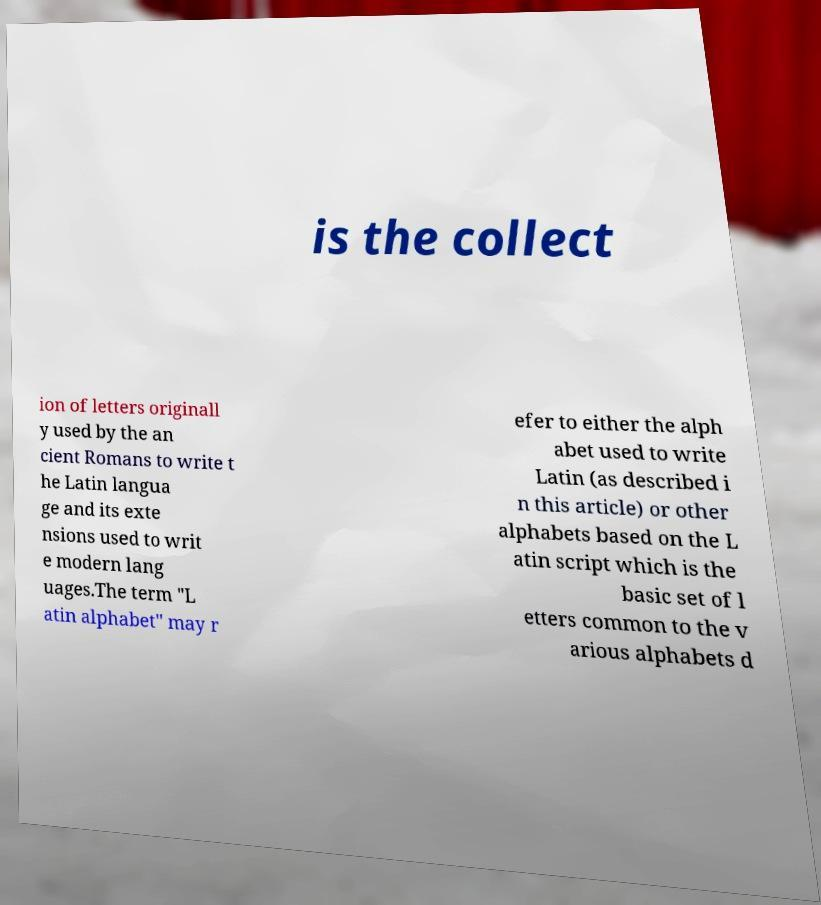I need the written content from this picture converted into text. Can you do that? is the collect ion of letters originall y used by the an cient Romans to write t he Latin langua ge and its exte nsions used to writ e modern lang uages.The term "L atin alphabet" may r efer to either the alph abet used to write Latin (as described i n this article) or other alphabets based on the L atin script which is the basic set of l etters common to the v arious alphabets d 